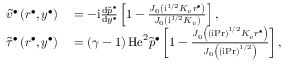<formula> <loc_0><loc_0><loc_500><loc_500>\begin{array} { r l } { \widetilde { v } ^ { \bullet } \left ( r ^ { \bullet } , y ^ { \bullet } \right ) } & = - i \frac { d \widetilde { p } ^ { \bullet } } { d y ^ { \bullet } } \left [ 1 - \frac { J _ { 0 } \left ( i ^ { 1 / 2 } K _ { v } r ^ { \bullet } \right ) } { J _ { 0 } \left ( i ^ { 1 / 2 } K _ { v } \right ) } \right ] , } \\ { \widetilde { \tau } ^ { \bullet } \left ( r ^ { \bullet } , y ^ { \bullet } \right ) } & = \left ( \gamma - 1 \right ) H e ^ { 2 } \widetilde { p } ^ { \bullet } \left [ 1 - \frac { J _ { 0 } \left ( \left ( i P r \right ) ^ { 1 / 2 } K _ { v } r ^ { \bullet } \right ) } { J _ { 0 } \left ( \left ( i P r \right ) ^ { 1 / 2 } \right ) } \right ] , } \end{array}</formula> 